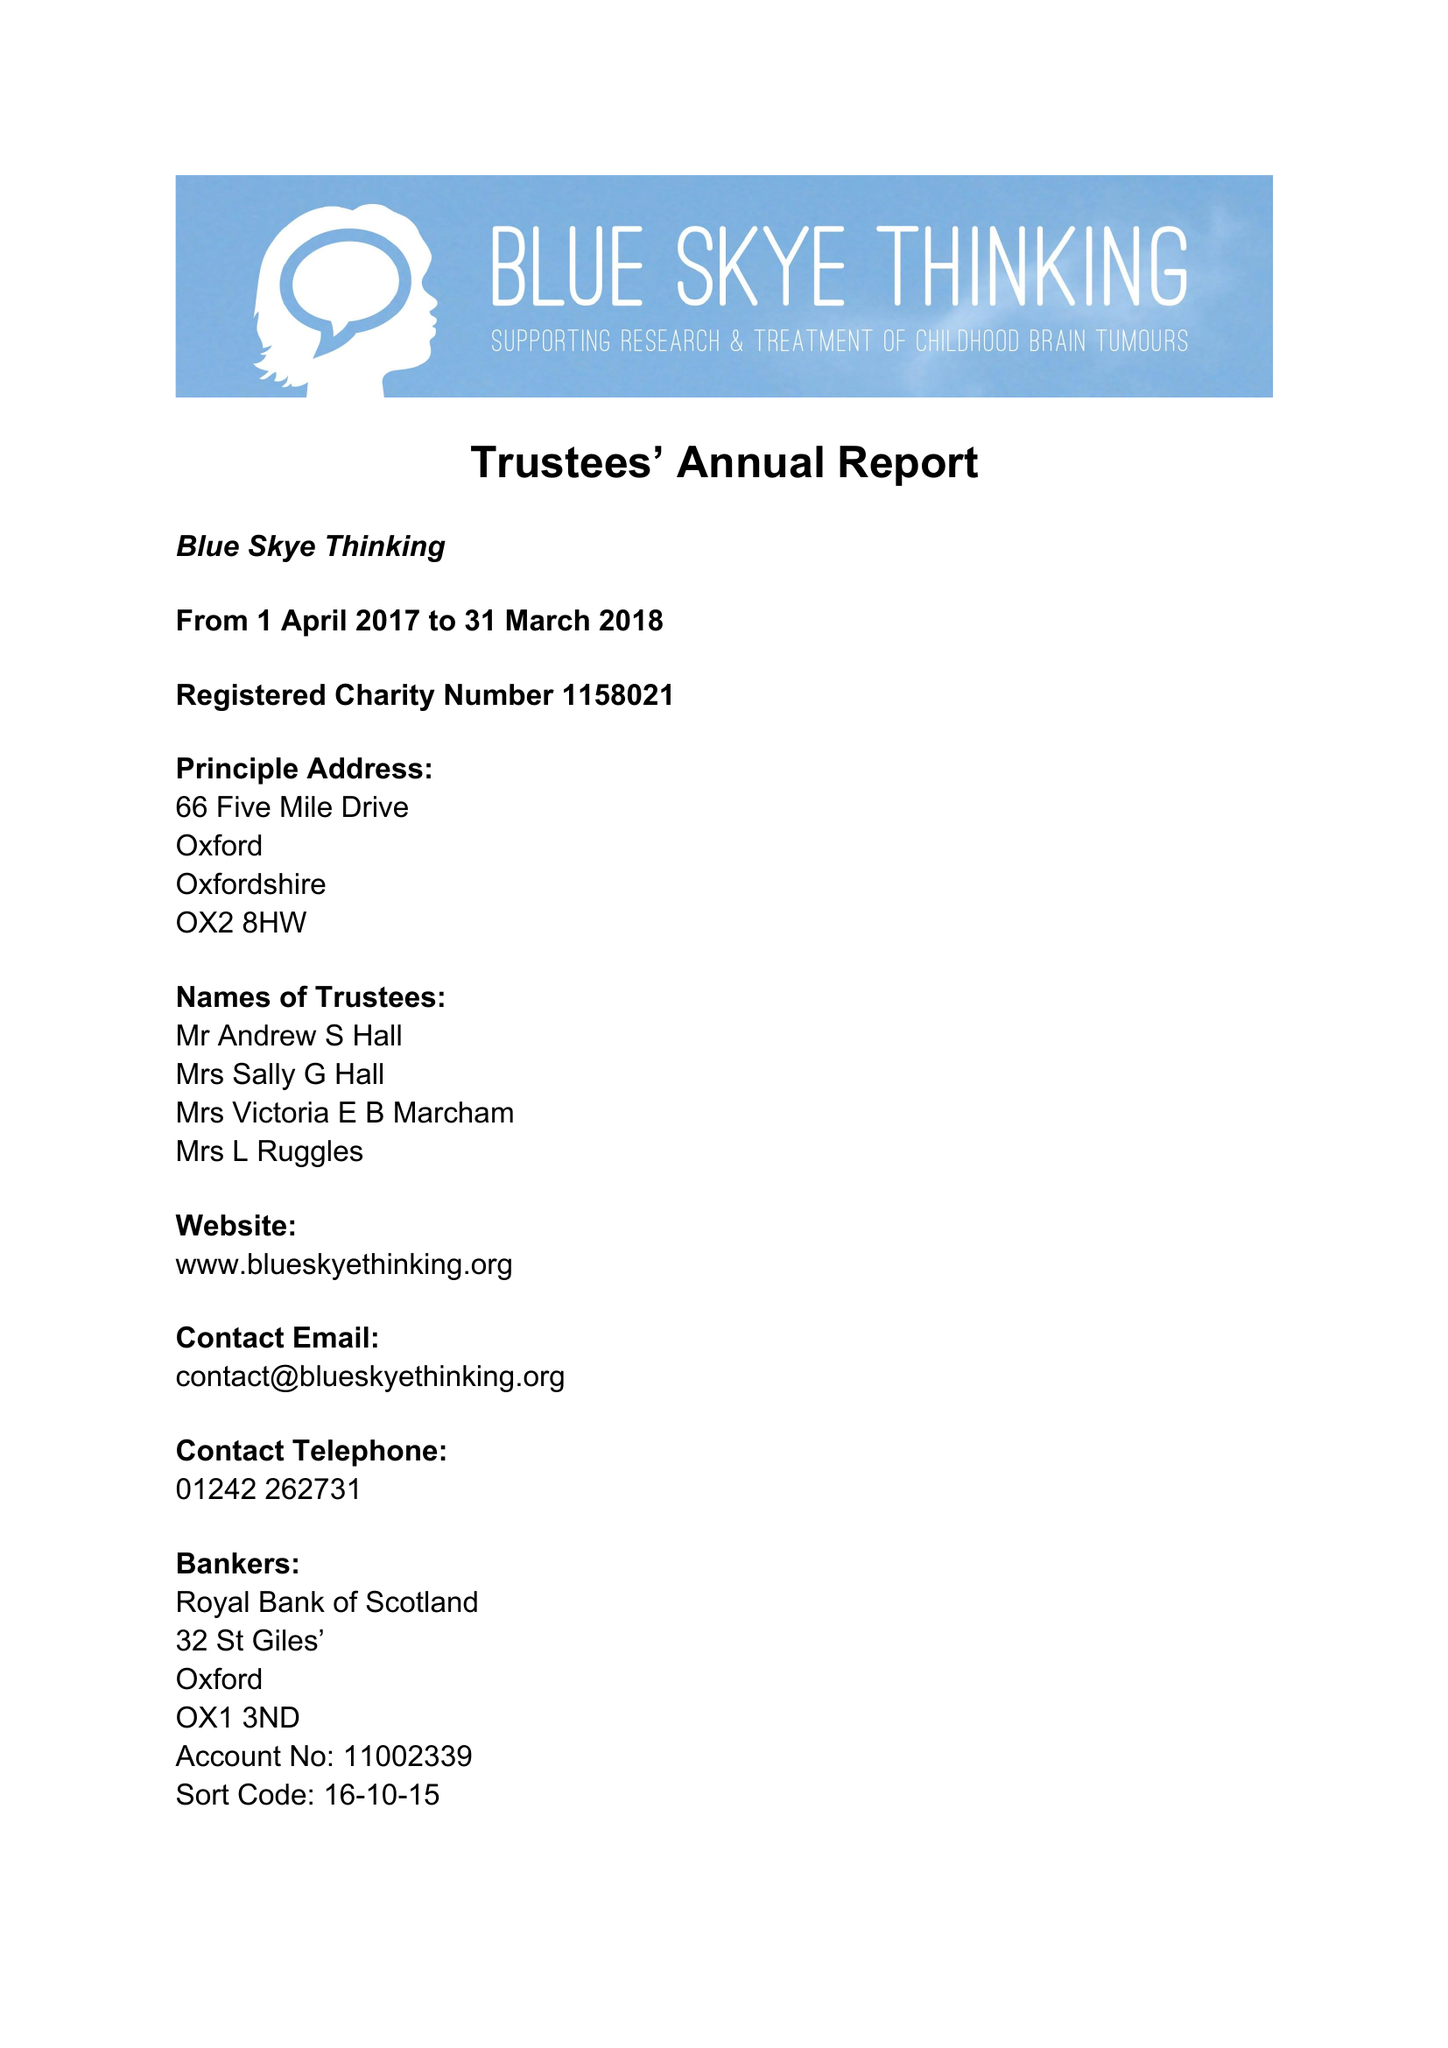What is the value for the spending_annually_in_british_pounds?
Answer the question using a single word or phrase. 82387.00 